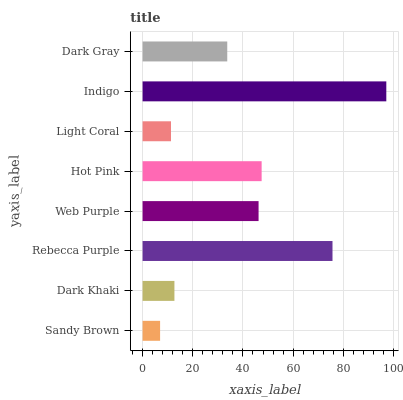Is Sandy Brown the minimum?
Answer yes or no. Yes. Is Indigo the maximum?
Answer yes or no. Yes. Is Dark Khaki the minimum?
Answer yes or no. No. Is Dark Khaki the maximum?
Answer yes or no. No. Is Dark Khaki greater than Sandy Brown?
Answer yes or no. Yes. Is Sandy Brown less than Dark Khaki?
Answer yes or no. Yes. Is Sandy Brown greater than Dark Khaki?
Answer yes or no. No. Is Dark Khaki less than Sandy Brown?
Answer yes or no. No. Is Web Purple the high median?
Answer yes or no. Yes. Is Dark Gray the low median?
Answer yes or no. Yes. Is Dark Khaki the high median?
Answer yes or no. No. Is Web Purple the low median?
Answer yes or no. No. 